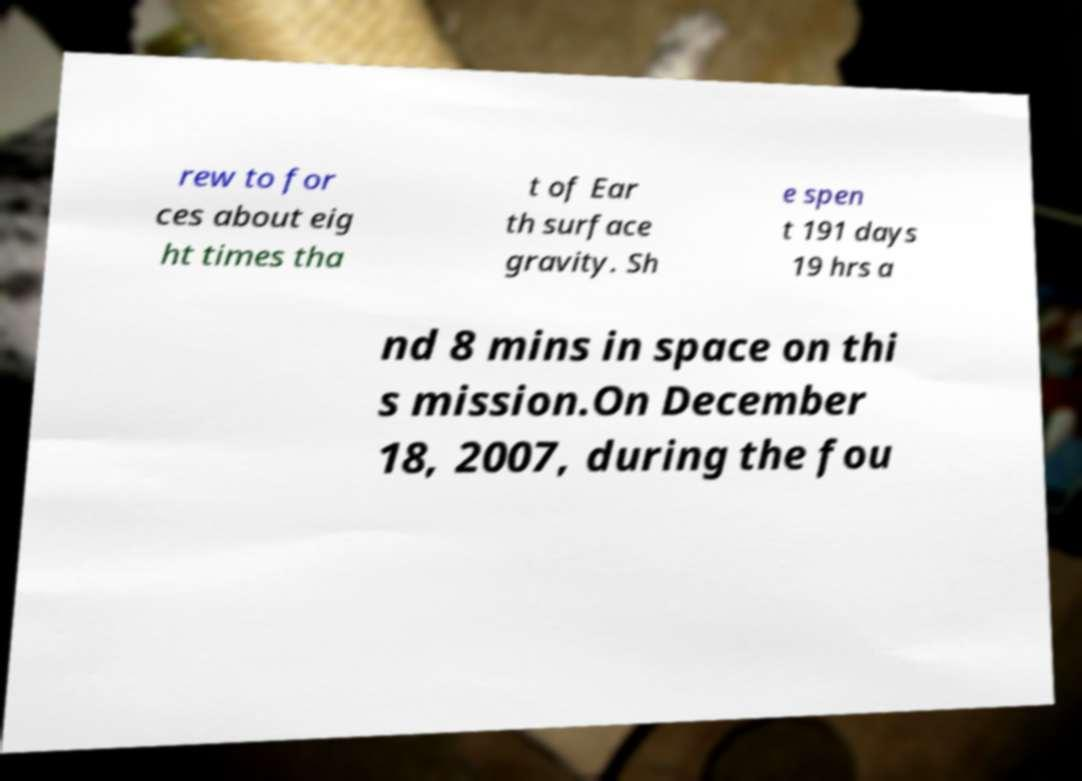I need the written content from this picture converted into text. Can you do that? rew to for ces about eig ht times tha t of Ear th surface gravity. Sh e spen t 191 days 19 hrs a nd 8 mins in space on thi s mission.On December 18, 2007, during the fou 